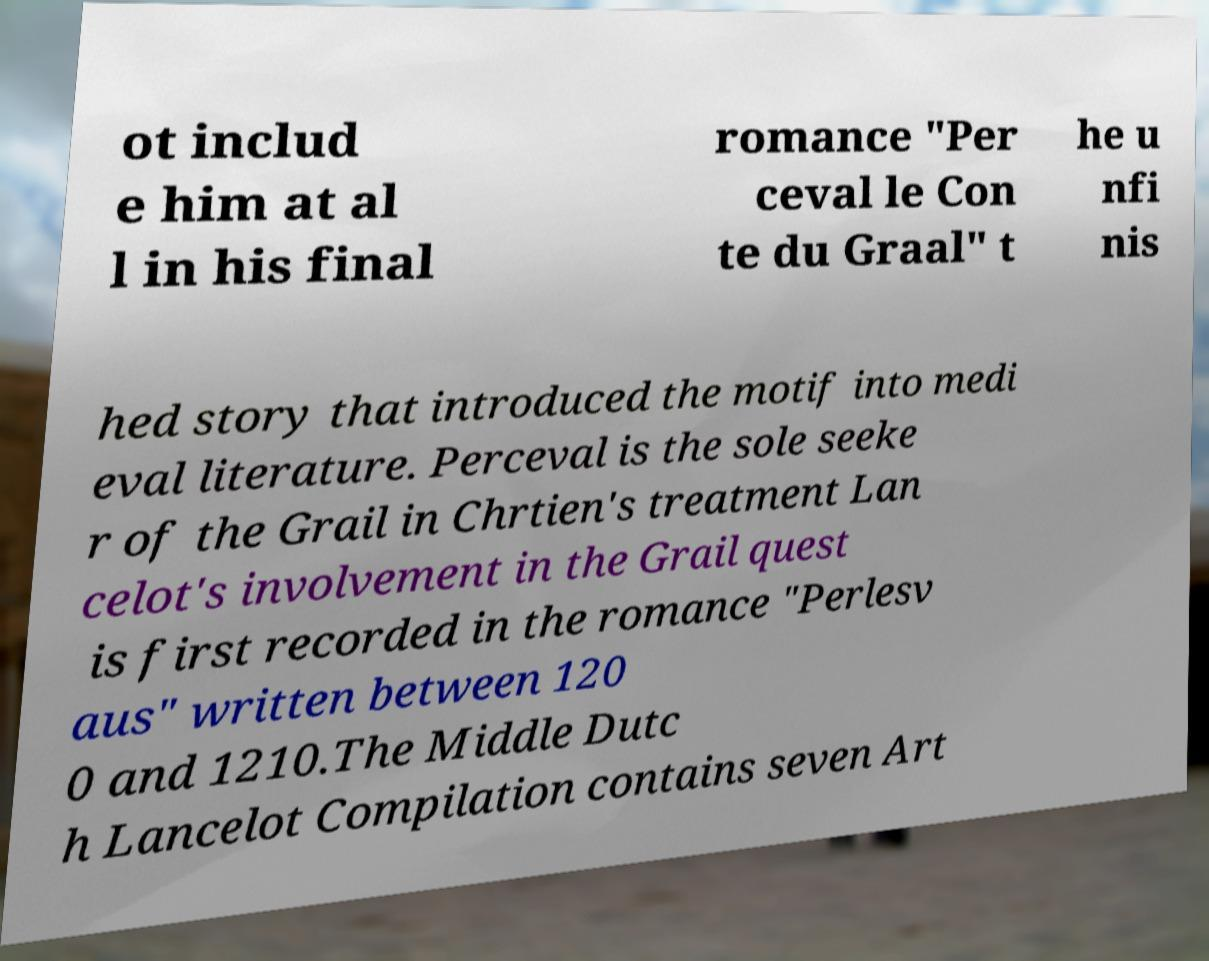For documentation purposes, I need the text within this image transcribed. Could you provide that? ot includ e him at al l in his final romance "Per ceval le Con te du Graal" t he u nfi nis hed story that introduced the motif into medi eval literature. Perceval is the sole seeke r of the Grail in Chrtien's treatment Lan celot's involvement in the Grail quest is first recorded in the romance "Perlesv aus" written between 120 0 and 1210.The Middle Dutc h Lancelot Compilation contains seven Art 